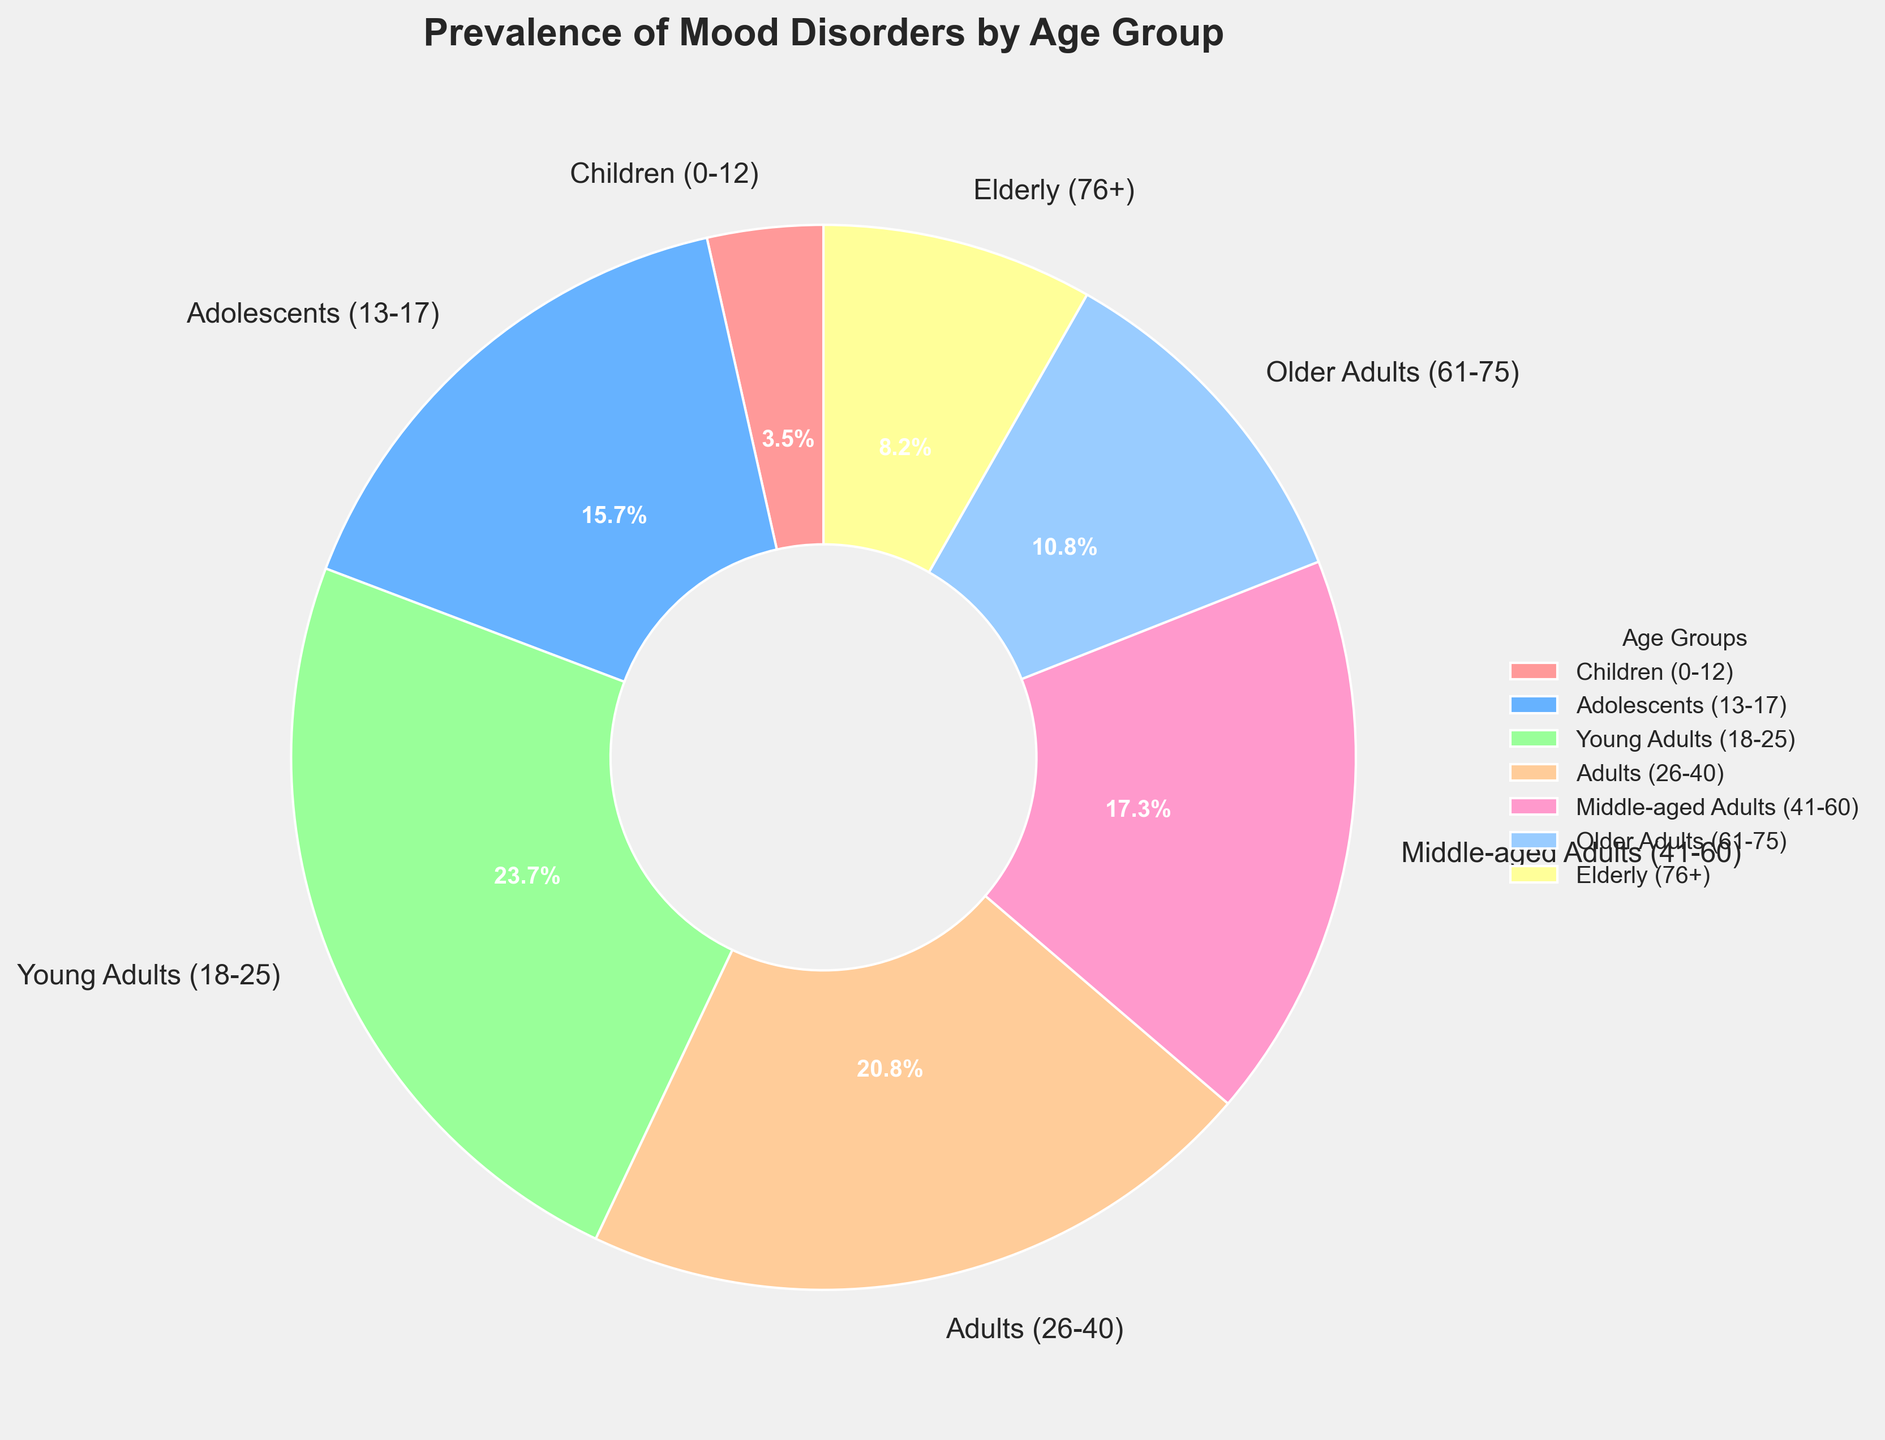Which age group has the highest prevalence of mood disorders? By looking at the pie chart, we can see that the Young Adults (18-25) segment has the largest portion of the pie. This means Young Adults have the highest prevalence.
Answer: Young Adults (18-25) What is the combined prevalence of mood disorders for Adults (26-40) and Middle-aged Adults (41-60)? First, identify the individual prevalences: Adults (26-40) is 18.9% and Middle-aged Adults (41-60) is 15.7%. Adding them together: 18.9% + 15.7% = 34.6%.
Answer: 34.6% How much larger is the prevalence of mood disorders in Adolescents (13-17) compared to Children (0-12)? Adolescents have a prevalence of 14.3%, while Children have 3.2%. The difference is 14.3% - 3.2% = 11.1%.
Answer: 11.1% Which age group has roughly half the prevalence of Young Adults (18-25)? The prevalence for Young Adults (18-25) is 21.6%. Half of this value is 21.6 / 2 = 10.8%. The closest age group's prevalence to 10.8% is Older Adults (9.8%).
Answer: Older Adults (61-75) What is the prevalence difference between the age group with the least and the age group with the highest prevalence of mood disorders? The Elderly (76+) have the least prevalence at 7.5%, and Young Adults (18-25) have the highest at 21.6%. The difference is 21.6% - 7.5% = 14.1%.
Answer: 14.1% Which two age groups have the most similar prevalence of mood disorders? Comparing all age groups visually, we see that Older Adults (61-75) at 9.8% and Elderly (76+) at 7.5% have the most similar values.
Answer: Older Adults (61-75) and Elderly (76+) What proportion of the pie chart is made up by the prevalence of Young Adults (18-25) and Adolescents (13-17) together? The Young Adults segment is 21.6% and Adolescents is 14.3%. Adding these gives 21.6% + 14.3% = 35.9%.
Answer: 35.9% How does the prevalence in Middle-aged Adults (41-60) compare visually to that in Older Adults (61-75)? Middle-aged Adults have a prevalence of 15.7%, which visually appears larger than the segment for Older Adults at 9.8%. This can be seen by comparing the sizes of the pie segments.
Answer: Larger 